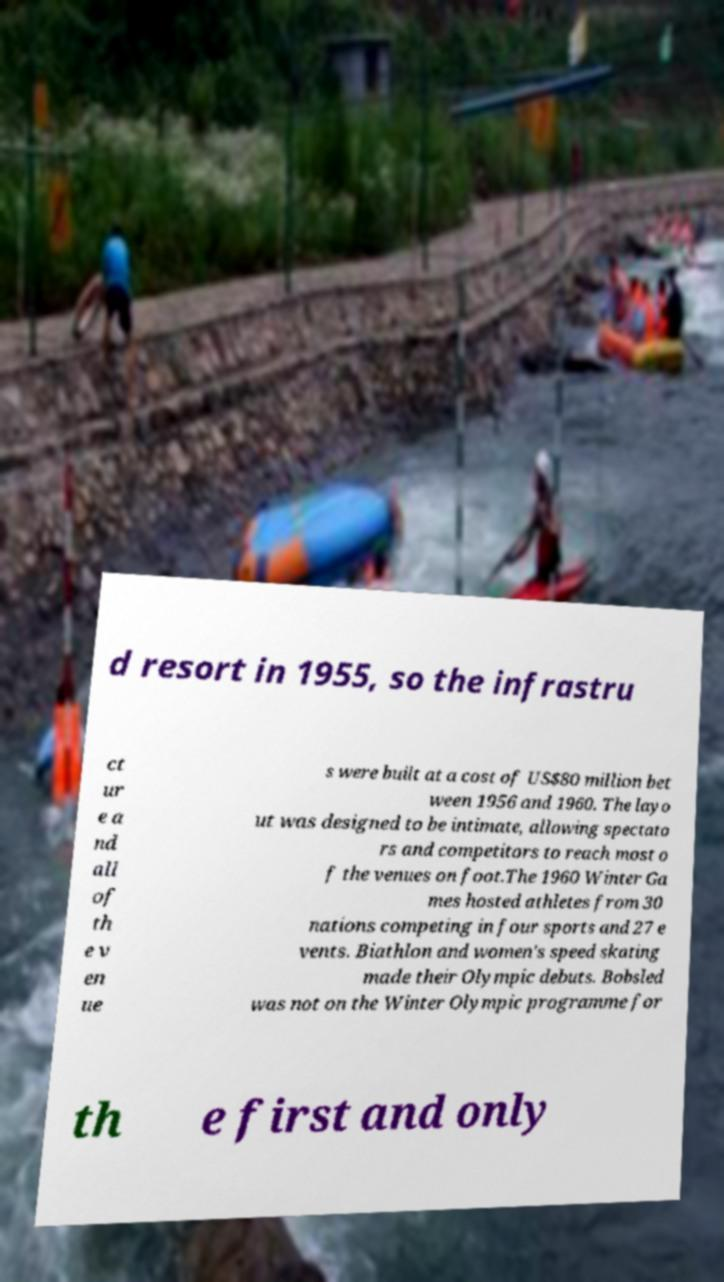Please identify and transcribe the text found in this image. d resort in 1955, so the infrastru ct ur e a nd all of th e v en ue s were built at a cost of US$80 million bet ween 1956 and 1960. The layo ut was designed to be intimate, allowing spectato rs and competitors to reach most o f the venues on foot.The 1960 Winter Ga mes hosted athletes from 30 nations competing in four sports and 27 e vents. Biathlon and women's speed skating made their Olympic debuts. Bobsled was not on the Winter Olympic programme for th e first and only 